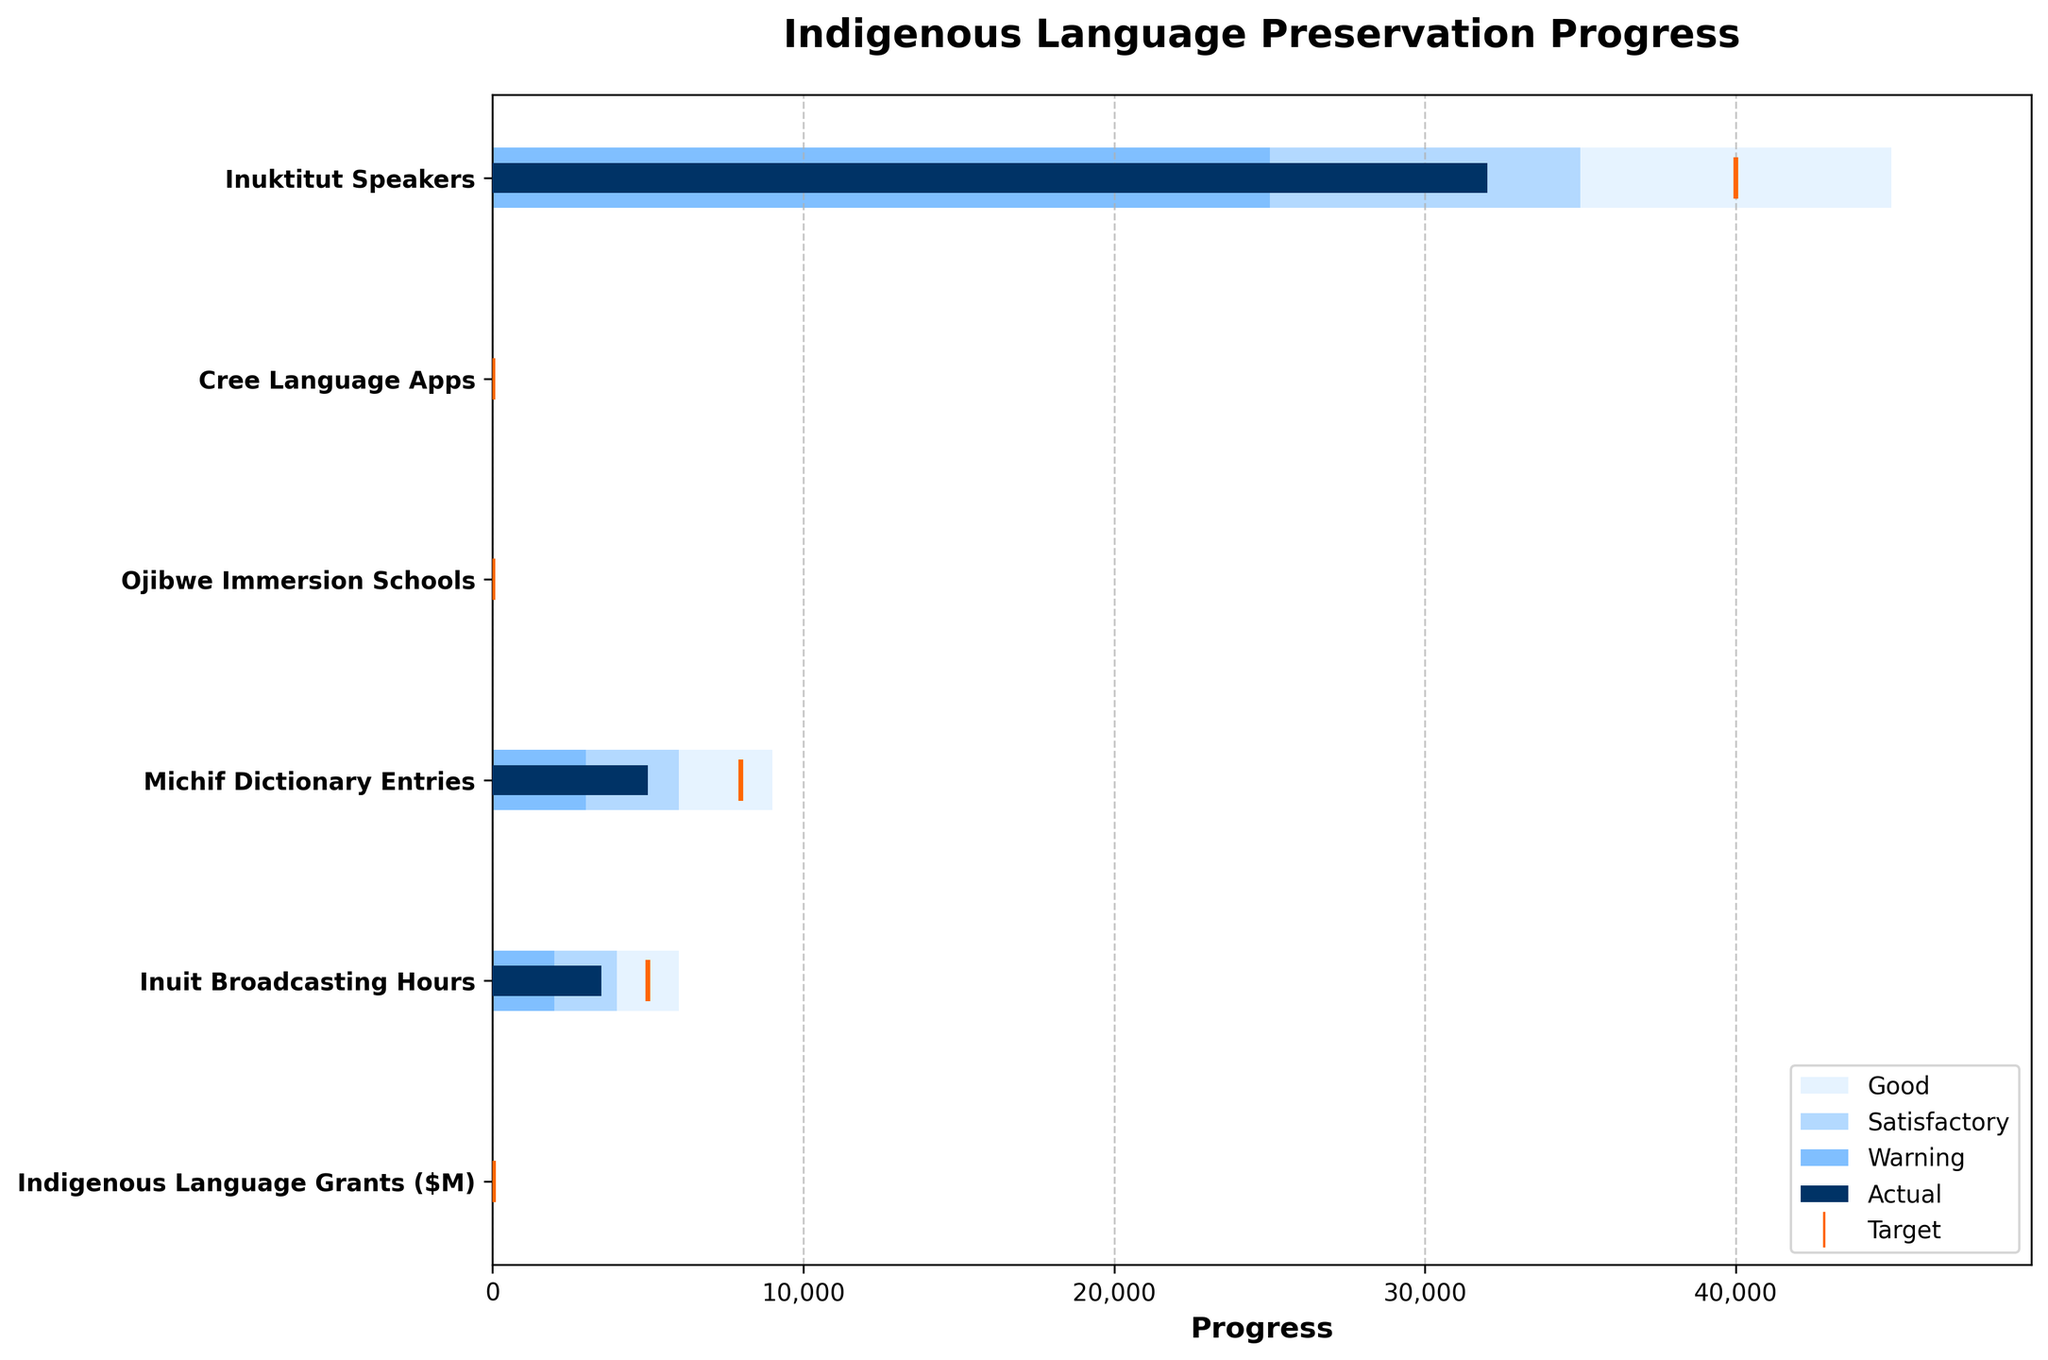What is the title of the figure? The title is generally displayed at the top of the figure. It describes the overall topic or focus of the chart.
Answer: Indigenous Language Preservation Progress How many categories are there in total? The number of categories can be identified by counting the distinct names labeled on the y-axis of the chart.
Answer: 6 Which category has the highest target value? Examine the target values plotted as markers in the chart and identify which number is the largest.
Answer: Inuit Broadcasting Hours Which category shows the lowest actual value? Look at the bars representing the actual values and determine which is the shortest.
Answer: Cree Language Apps In which category is the actual value closest to the target value? Compare the lengths of the bars (actuals) to the positions of the markers (targets) to find the smallest difference.
Answer: Indigenous Language Grants Which category is performing below the warning level? Check the categories where the actual value bars do not even reach the warning level bars.
Answer: None How many categories have their actual values exceeding the satisfactory level? Look at the satisfactory level bars and count how many actual value bars extend beyond these.
Answer: 5 What is the sum of the actual values for all categories? Add up all the actual values: 32000 + 8 + 14 + 5000 + 3500 + 25.
Answer: 40,547 Compare the actual values of Inuktitut Speakers and Ojibwe Immersion Schools. Which one is higher and by how much? Compare the actual values represented by the bar lengths for these two categories. Inuktitut Speakers: 32000, Ojibwe Immersion Schools: 14 - calculate the difference which is 32000 - 14.
Answer: Inuktitut Speakers, by 31,986 Are there any categories where the actual value surpasses the good level? Check for any actual value bars that extend beyond the good level bars.
Answer: None What is the average actual value for the categories listed? Sum the actual values and divide by the total number of categories: (32000 + 8 + 14 + 5000 + 3500 + 25) / 6.
Answer: 6,758 